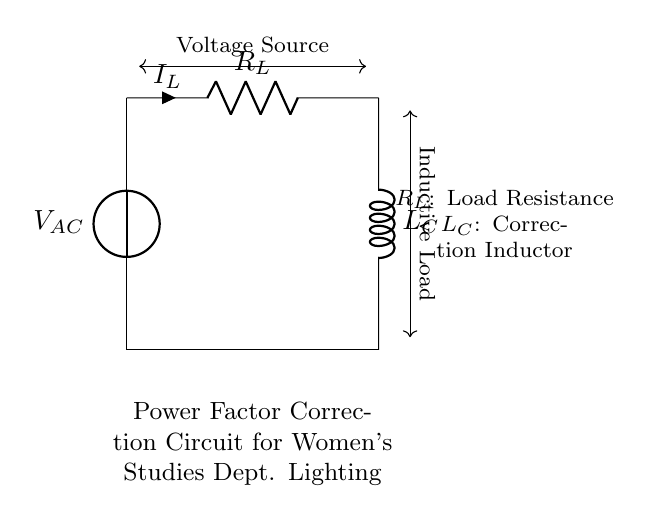What is the voltage source in this circuit? The voltage source is labeled as V_AC, which indicates the alternating current supply that powers the circuit.
Answer: V_AC What is the load in this circuit? The load is represented by the resistor R_L, which is connected in series with the voltage source to consume power.
Answer: R_L What is connected in parallel to the load? There is no component connected in parallel to the load; the circuit configuration shows a series connection from the voltage source to the load and then to the correction inductor.
Answer: None What type of component is L_C? L_C is an inductor; it is labeled in the circuit as a correction inductor aimed at improving the power factor in the lighting system.
Answer: Inductor How does this circuit achieve power factor correction? The circuit uses a correction inductor L_C to offset the lagging power factor caused by the load R_L, which helps to balance the reactive power and improve the overall efficiency of the lighting system.
Answer: By using L_C What is the relationship between current and load in this circuit? The current I_L flows through the load resistance R_L, which means that it is the same current that passes through L_C because they are in series, maintaining a single path for the current to follow.
Answer: Same current 